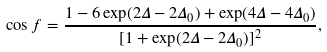Convert formula to latex. <formula><loc_0><loc_0><loc_500><loc_500>\cos f = \frac { 1 - 6 \exp ( { 2 \Delta - 2 \Delta _ { 0 } } ) + \exp ( { 4 \Delta - 4 \Delta _ { 0 } } ) } { [ 1 + \exp ( { 2 \Delta - 2 \Delta _ { 0 } } ) ] ^ { 2 } } ,</formula> 